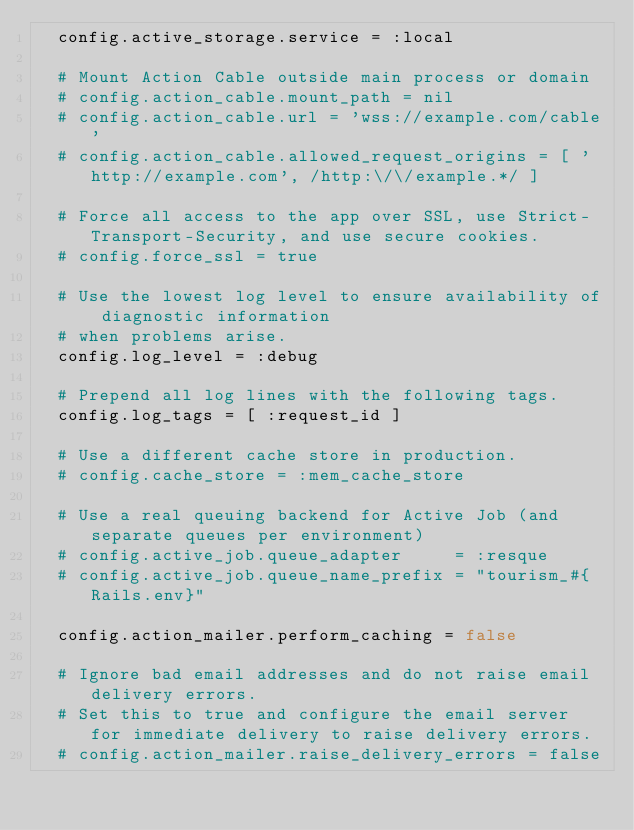<code> <loc_0><loc_0><loc_500><loc_500><_Ruby_>  config.active_storage.service = :local

  # Mount Action Cable outside main process or domain
  # config.action_cable.mount_path = nil
  # config.action_cable.url = 'wss://example.com/cable'
  # config.action_cable.allowed_request_origins = [ 'http://example.com', /http:\/\/example.*/ ]

  # Force all access to the app over SSL, use Strict-Transport-Security, and use secure cookies.
  # config.force_ssl = true

  # Use the lowest log level to ensure availability of diagnostic information
  # when problems arise.
  config.log_level = :debug

  # Prepend all log lines with the following tags.
  config.log_tags = [ :request_id ]

  # Use a different cache store in production.
  # config.cache_store = :mem_cache_store

  # Use a real queuing backend for Active Job (and separate queues per environment)
  # config.active_job.queue_adapter     = :resque
  # config.active_job.queue_name_prefix = "tourism_#{Rails.env}"

  config.action_mailer.perform_caching = false

  # Ignore bad email addresses and do not raise email delivery errors.
  # Set this to true and configure the email server for immediate delivery to raise delivery errors.
  # config.action_mailer.raise_delivery_errors = false
</code> 